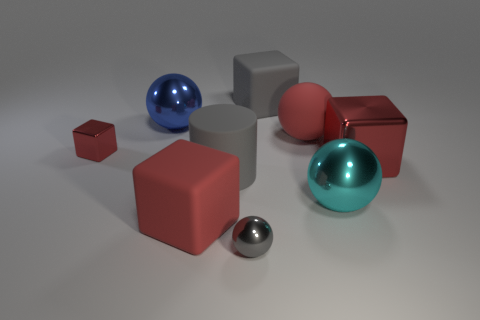Subtract all metallic balls. How many balls are left? 1 Subtract all gray cylinders. How many red cubes are left? 3 Add 1 big yellow rubber objects. How many objects exist? 10 Subtract all gray spheres. How many spheres are left? 3 Subtract all cubes. How many objects are left? 5 Subtract all blue cubes. Subtract all red cylinders. How many cubes are left? 4 Add 3 cyan matte blocks. How many cyan matte blocks exist? 3 Subtract 0 green cubes. How many objects are left? 9 Subtract all large purple rubber blocks. Subtract all tiny metallic balls. How many objects are left? 8 Add 7 big red cubes. How many big red cubes are left? 9 